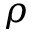Convert formula to latex. <formula><loc_0><loc_0><loc_500><loc_500>\rho</formula> 